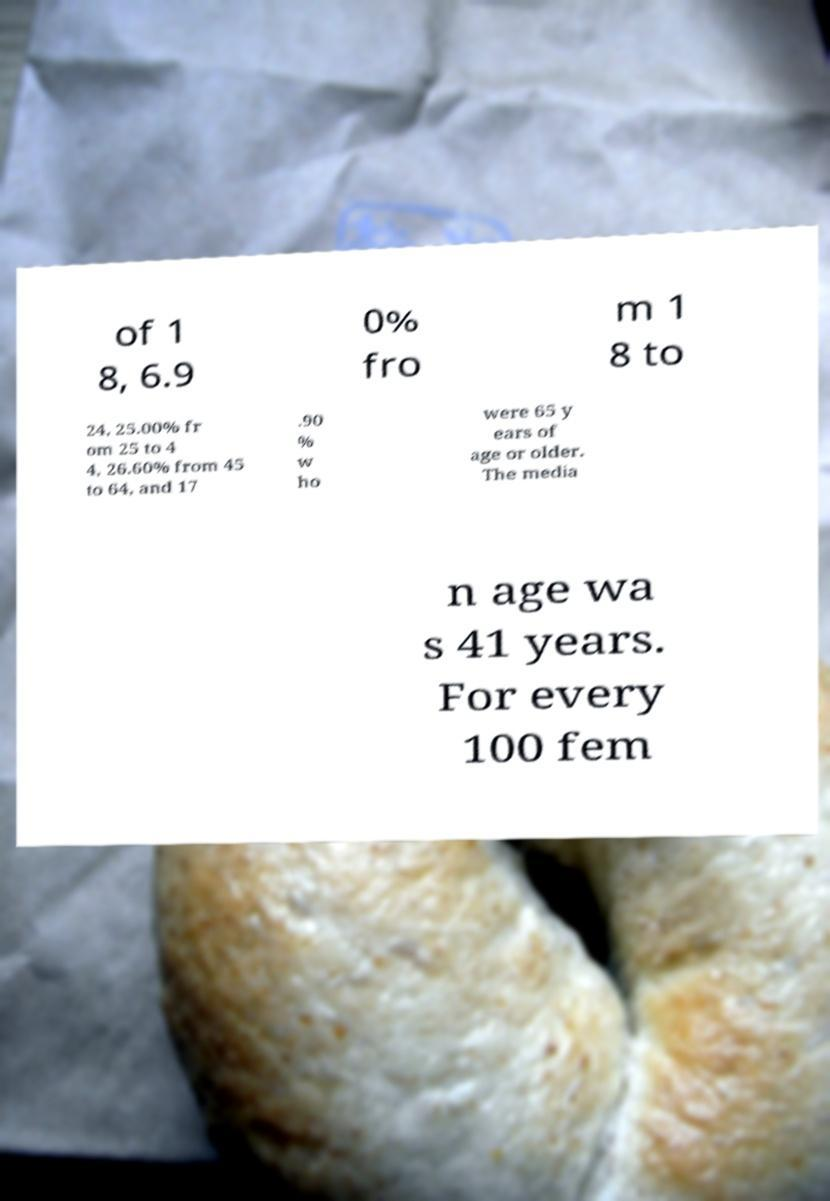There's text embedded in this image that I need extracted. Can you transcribe it verbatim? of 1 8, 6.9 0% fro m 1 8 to 24, 25.00% fr om 25 to 4 4, 26.60% from 45 to 64, and 17 .90 % w ho were 65 y ears of age or older. The media n age wa s 41 years. For every 100 fem 